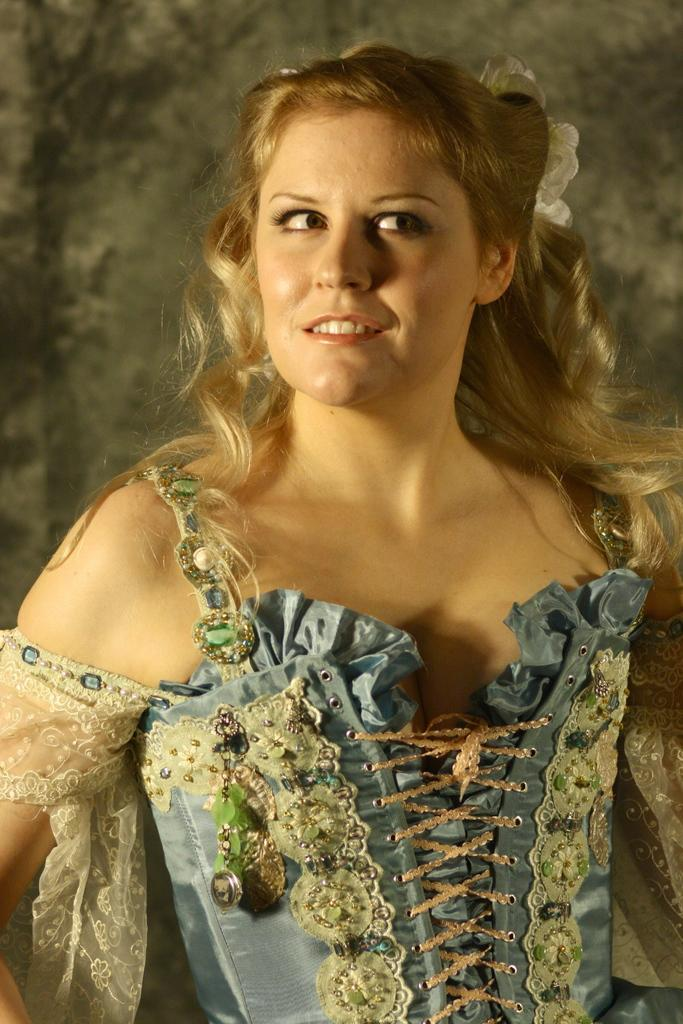What is the main subject of the image? The main subject of the image is a woman standing in the center. What is the woman doing in the image? The woman is smiling in the image. What is the woman wearing in the image? The woman is wearing a different costume in the image. What can be seen in the background of the image? There is a wall in the background of the image. What type of stamp can be seen on the woman's costume in the image? There is no stamp visible on the woman's costume in the image. What type of gold object is present in the image? There is no gold object present in the image. 